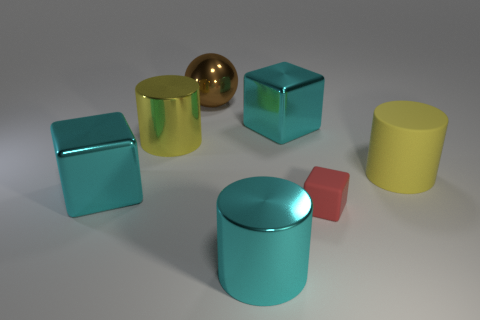Is the number of large shiny spheres that are behind the brown ball less than the number of brown shiny balls on the left side of the yellow rubber cylinder?
Your answer should be compact. Yes. What shape is the large yellow object on the right side of the large cyan metal cube that is on the right side of the large cyan metallic cylinder?
Keep it short and to the point. Cylinder. Are there any tiny red objects?
Offer a terse response. Yes. What color is the large block that is on the left side of the big brown metallic sphere?
Keep it short and to the point. Cyan. What material is the cylinder that is the same color as the big rubber thing?
Ensure brevity in your answer.  Metal. There is a tiny object; are there any blocks to the left of it?
Offer a very short reply. Yes. Is the number of tiny red blocks greater than the number of small red metal objects?
Make the answer very short. Yes. There is a metal cube in front of the big shiny thing right of the metallic object that is in front of the red matte block; what is its color?
Make the answer very short. Cyan. The other big cylinder that is made of the same material as the cyan cylinder is what color?
Your response must be concise. Yellow. Is there anything else that is the same size as the red object?
Keep it short and to the point. No. 